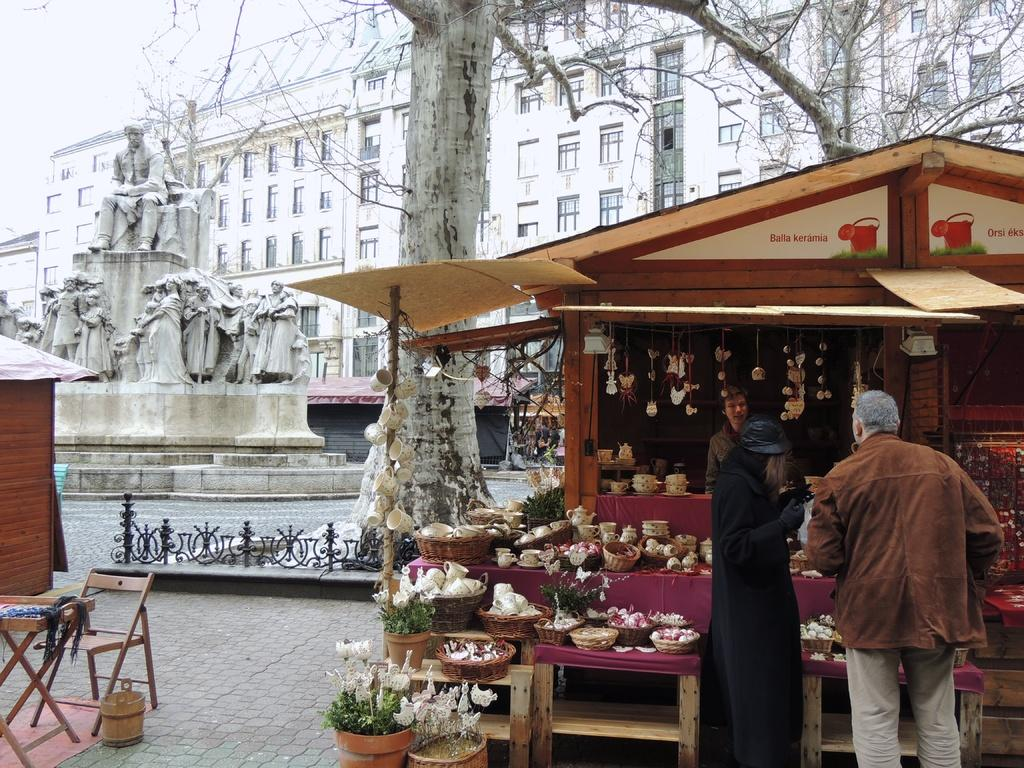What is the main subject in the center of the image? There is a shop in the center of the image. How many people are inside the shop? Three persons are standing in the shop. What can be seen inside the shop? There are objects visible in the shop. What is visible in the background of the image? There are buildings and trees in the background of the image. Can you see the ocean in the background of the image? No, there is no ocean visible in the background of the image. What type of apparatus is being used by the persons in the shop? There is no apparatus mentioned or visible in the image. 